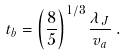<formula> <loc_0><loc_0><loc_500><loc_500>t _ { b } = \left ( \frac { 8 } { 5 } \right ) ^ { 1 / 3 } \frac { \lambda _ { J } } { v _ { a } } \, .</formula> 